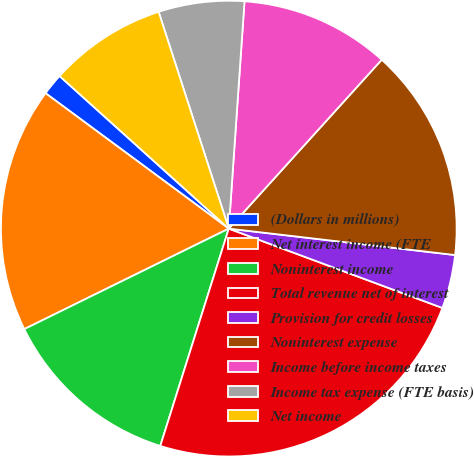Convert chart. <chart><loc_0><loc_0><loc_500><loc_500><pie_chart><fcel>(Dollars in millions)<fcel>Net interest income (FTE<fcel>Noninterest income<fcel>Total revenue net of interest<fcel>Provision for credit losses<fcel>Noninterest expense<fcel>Income before income taxes<fcel>Income tax expense (FTE basis)<fcel>Net income<nl><fcel>1.55%<fcel>17.4%<fcel>12.87%<fcel>24.2%<fcel>3.81%<fcel>15.14%<fcel>10.61%<fcel>6.08%<fcel>8.34%<nl></chart> 